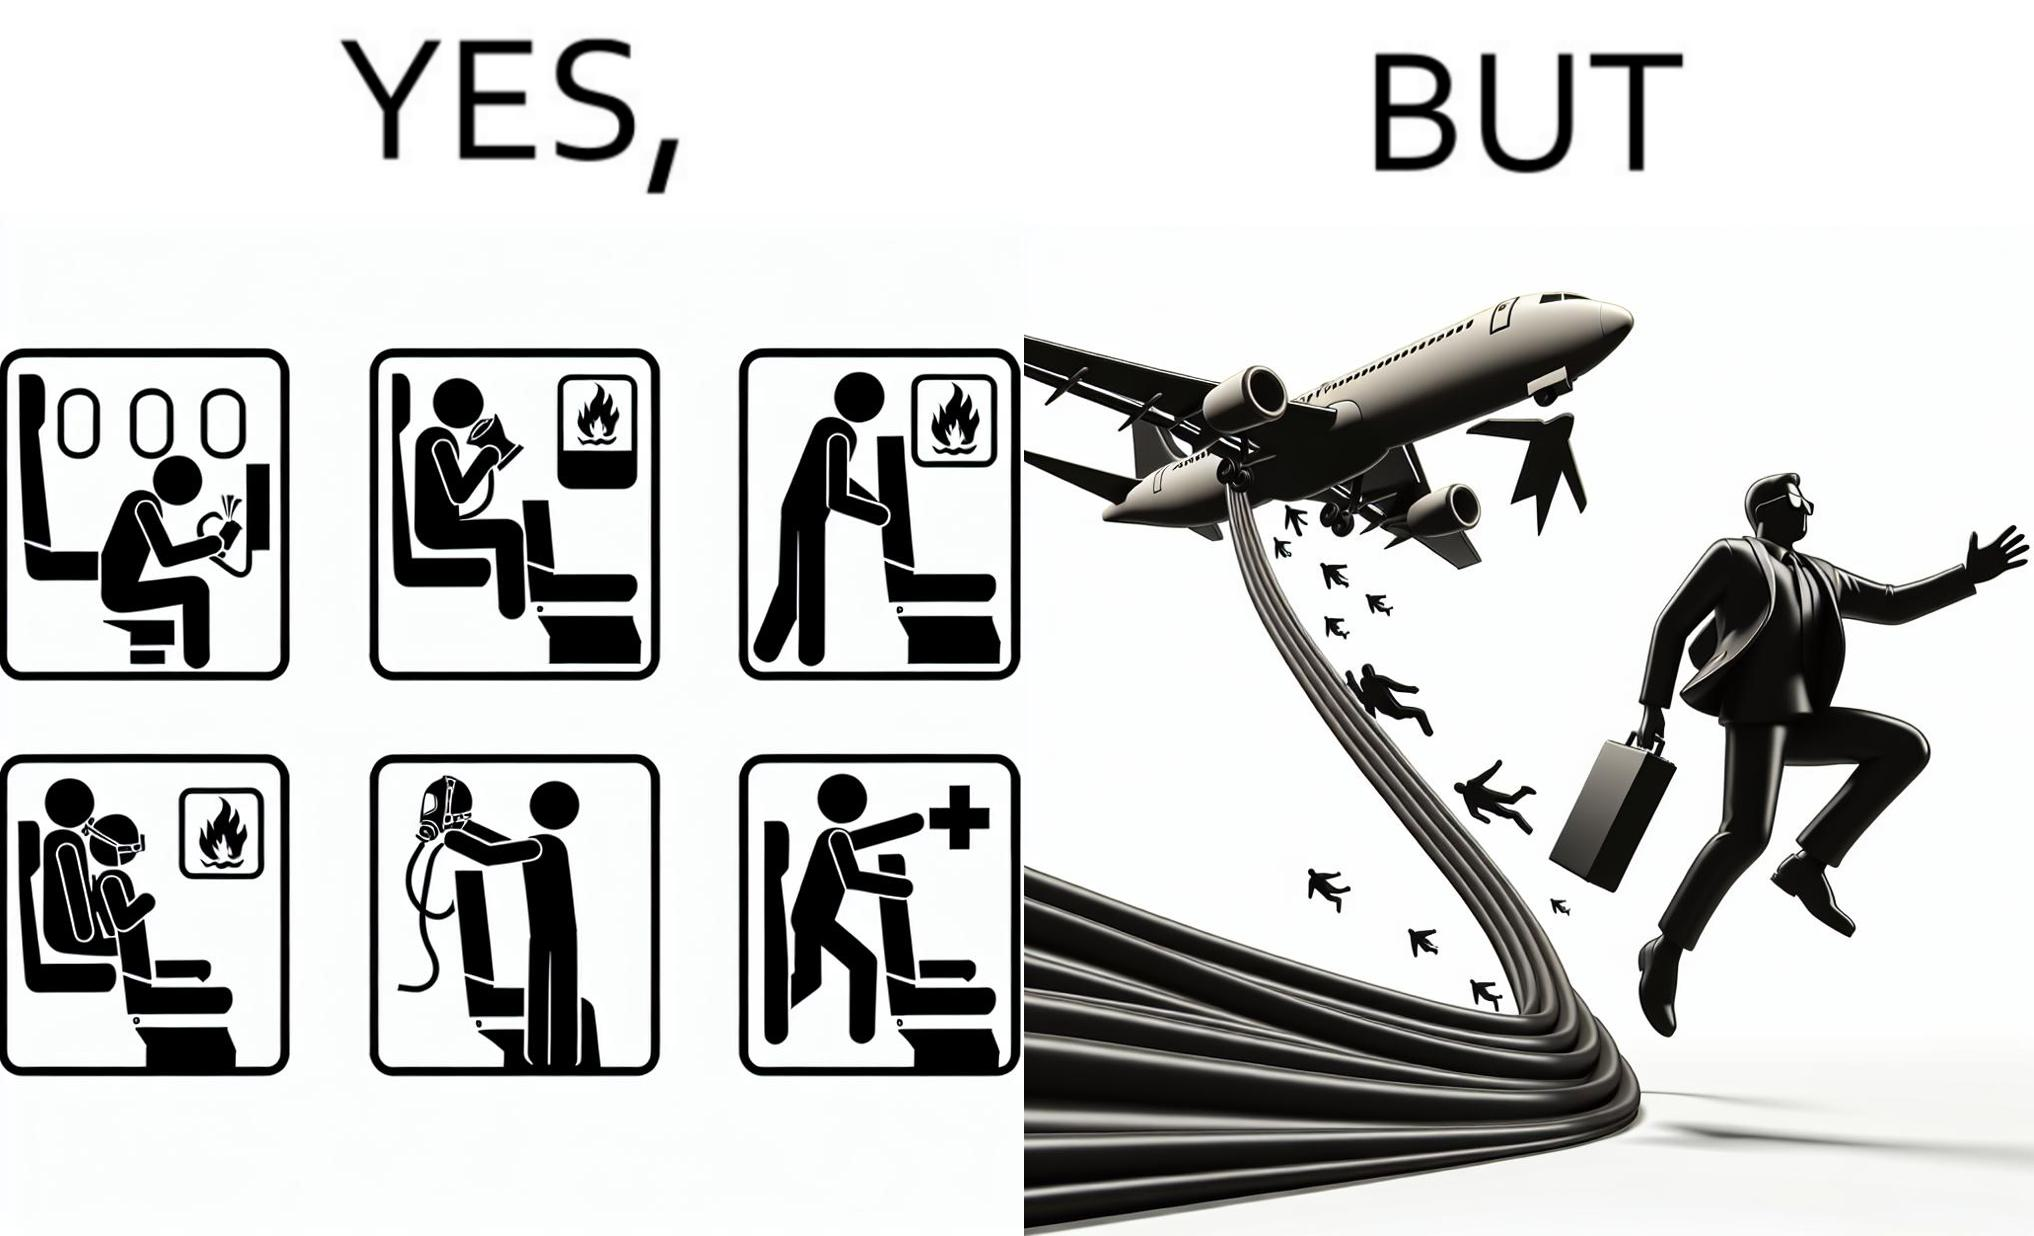Describe the contrast between the left and right parts of this image. In the left part of the image: They are images of what one should do in an airplane in case of an imminent collision and fire In the right part of the image: It shows a man jumping out of an airplane in case of an emergency and using the emergency inflatable slides 